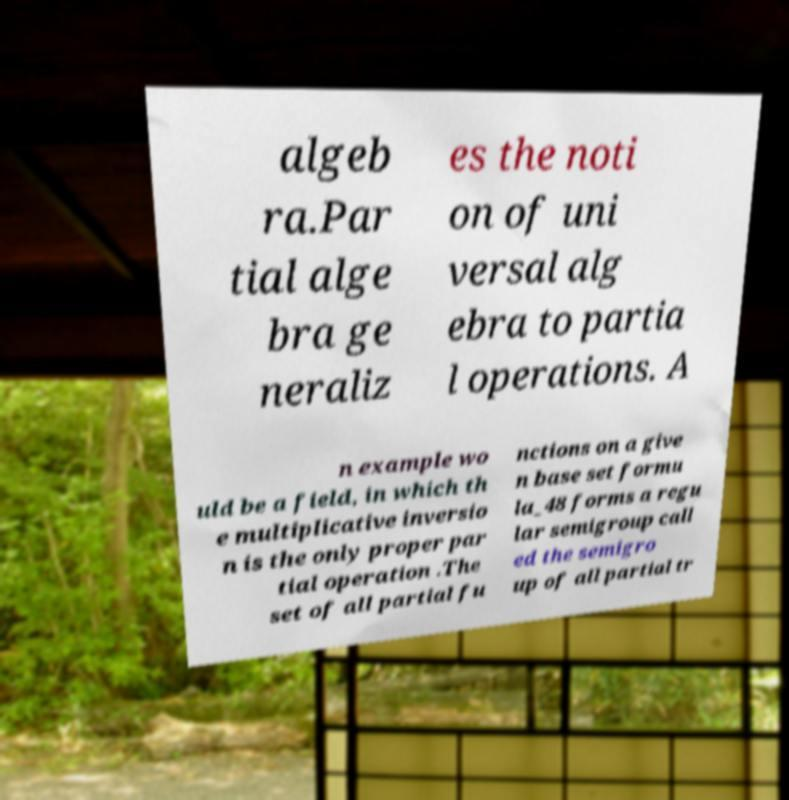I need the written content from this picture converted into text. Can you do that? algeb ra.Par tial alge bra ge neraliz es the noti on of uni versal alg ebra to partia l operations. A n example wo uld be a field, in which th e multiplicative inversio n is the only proper par tial operation .The set of all partial fu nctions on a give n base set formu la_48 forms a regu lar semigroup call ed the semigro up of all partial tr 